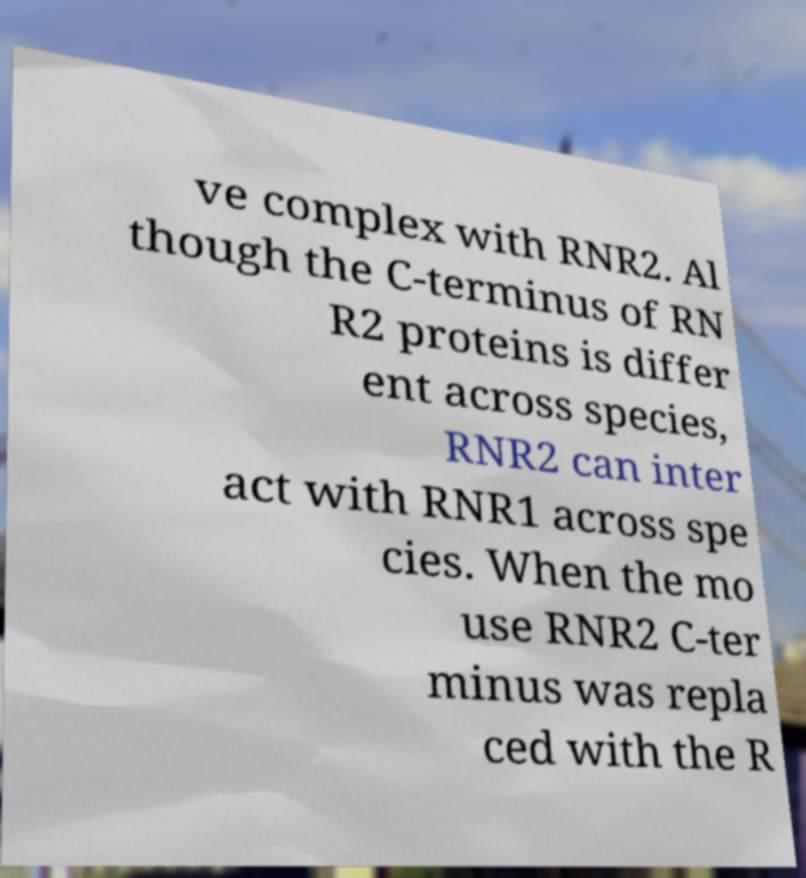I need the written content from this picture converted into text. Can you do that? ve complex with RNR2. Al though the C-terminus of RN R2 proteins is differ ent across species, RNR2 can inter act with RNR1 across spe cies. When the mo use RNR2 C-ter minus was repla ced with the R 